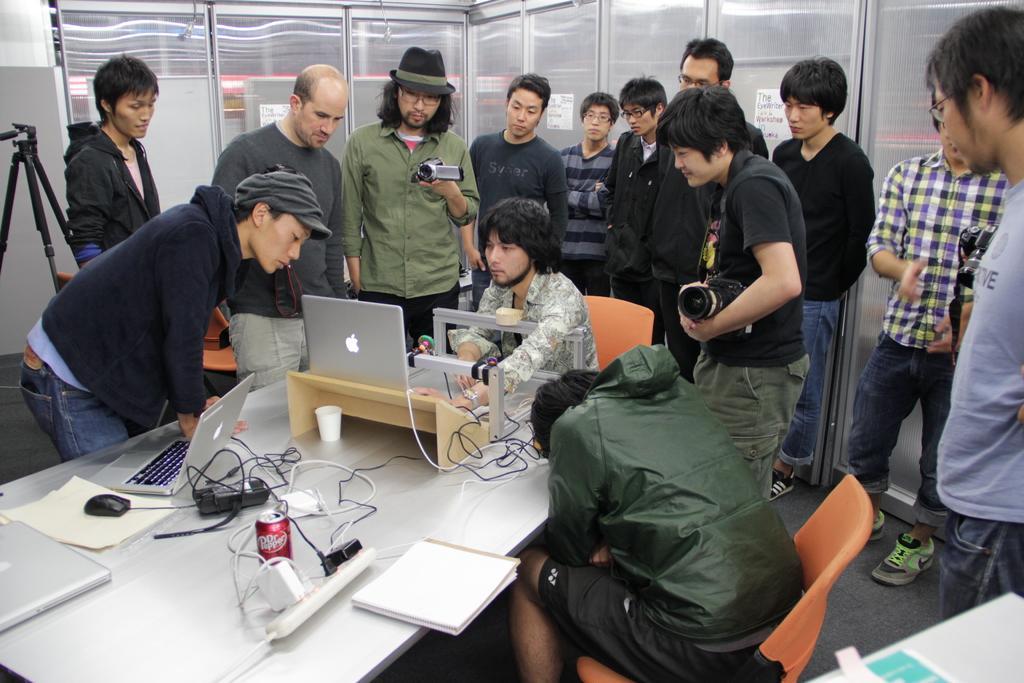Describe this image in one or two sentences. The picture is taken inside a room. in the middle there is a table. On the table there are laptops,can,book. In the middle one person is using laptop. Beside him one person is sitting on chair. There are many people standing in the back. Some of them holding camera. They are looking at the laptop. In the background there is glass wall. In the left side there is tripod stand. 